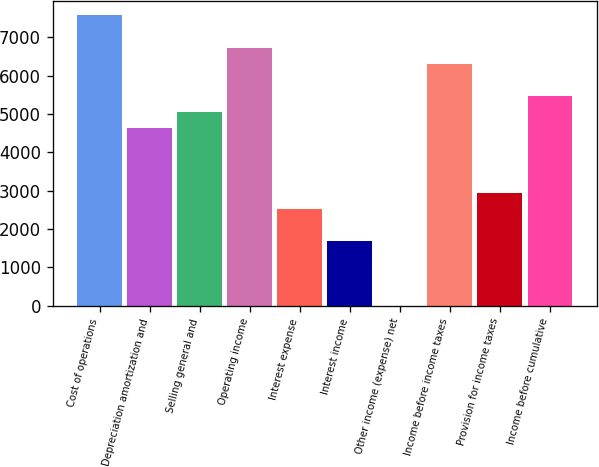<chart> <loc_0><loc_0><loc_500><loc_500><bar_chart><fcel>Cost of operations<fcel>Depreciation amortization and<fcel>Selling general and<fcel>Operating income<fcel>Interest expense<fcel>Interest income<fcel>Other income (expense) net<fcel>Income before income taxes<fcel>Provision for income taxes<fcel>Income before cumulative<nl><fcel>7576.14<fcel>4629.98<fcel>5050.86<fcel>6734.38<fcel>2525.58<fcel>1683.82<fcel>0.3<fcel>6313.5<fcel>2946.46<fcel>5471.74<nl></chart> 